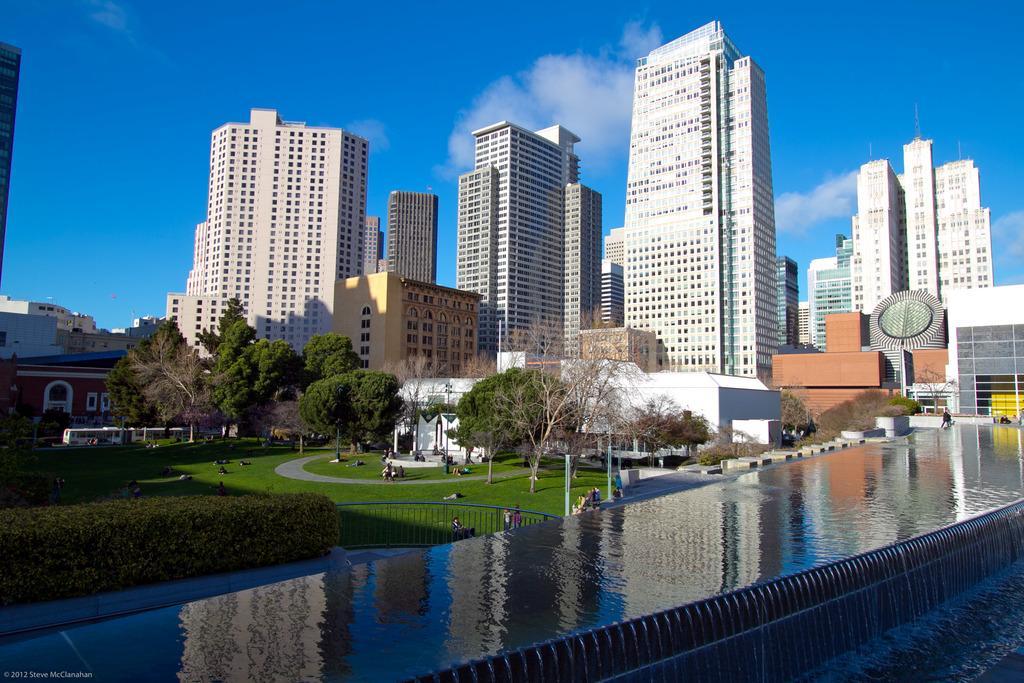Please provide a concise description of this image. In this picture we can see many buildings and skyscrapers. On the right, at the top of the building we can see the towers. At the bottom we can see the water. In the center we can see the group of persons sitting, lying and standing in the park. Beside the park there are vehicles which is parked near to the red building. At the top we can see sky and clouds. In the park we can see trees, plants, grass and fencing. 